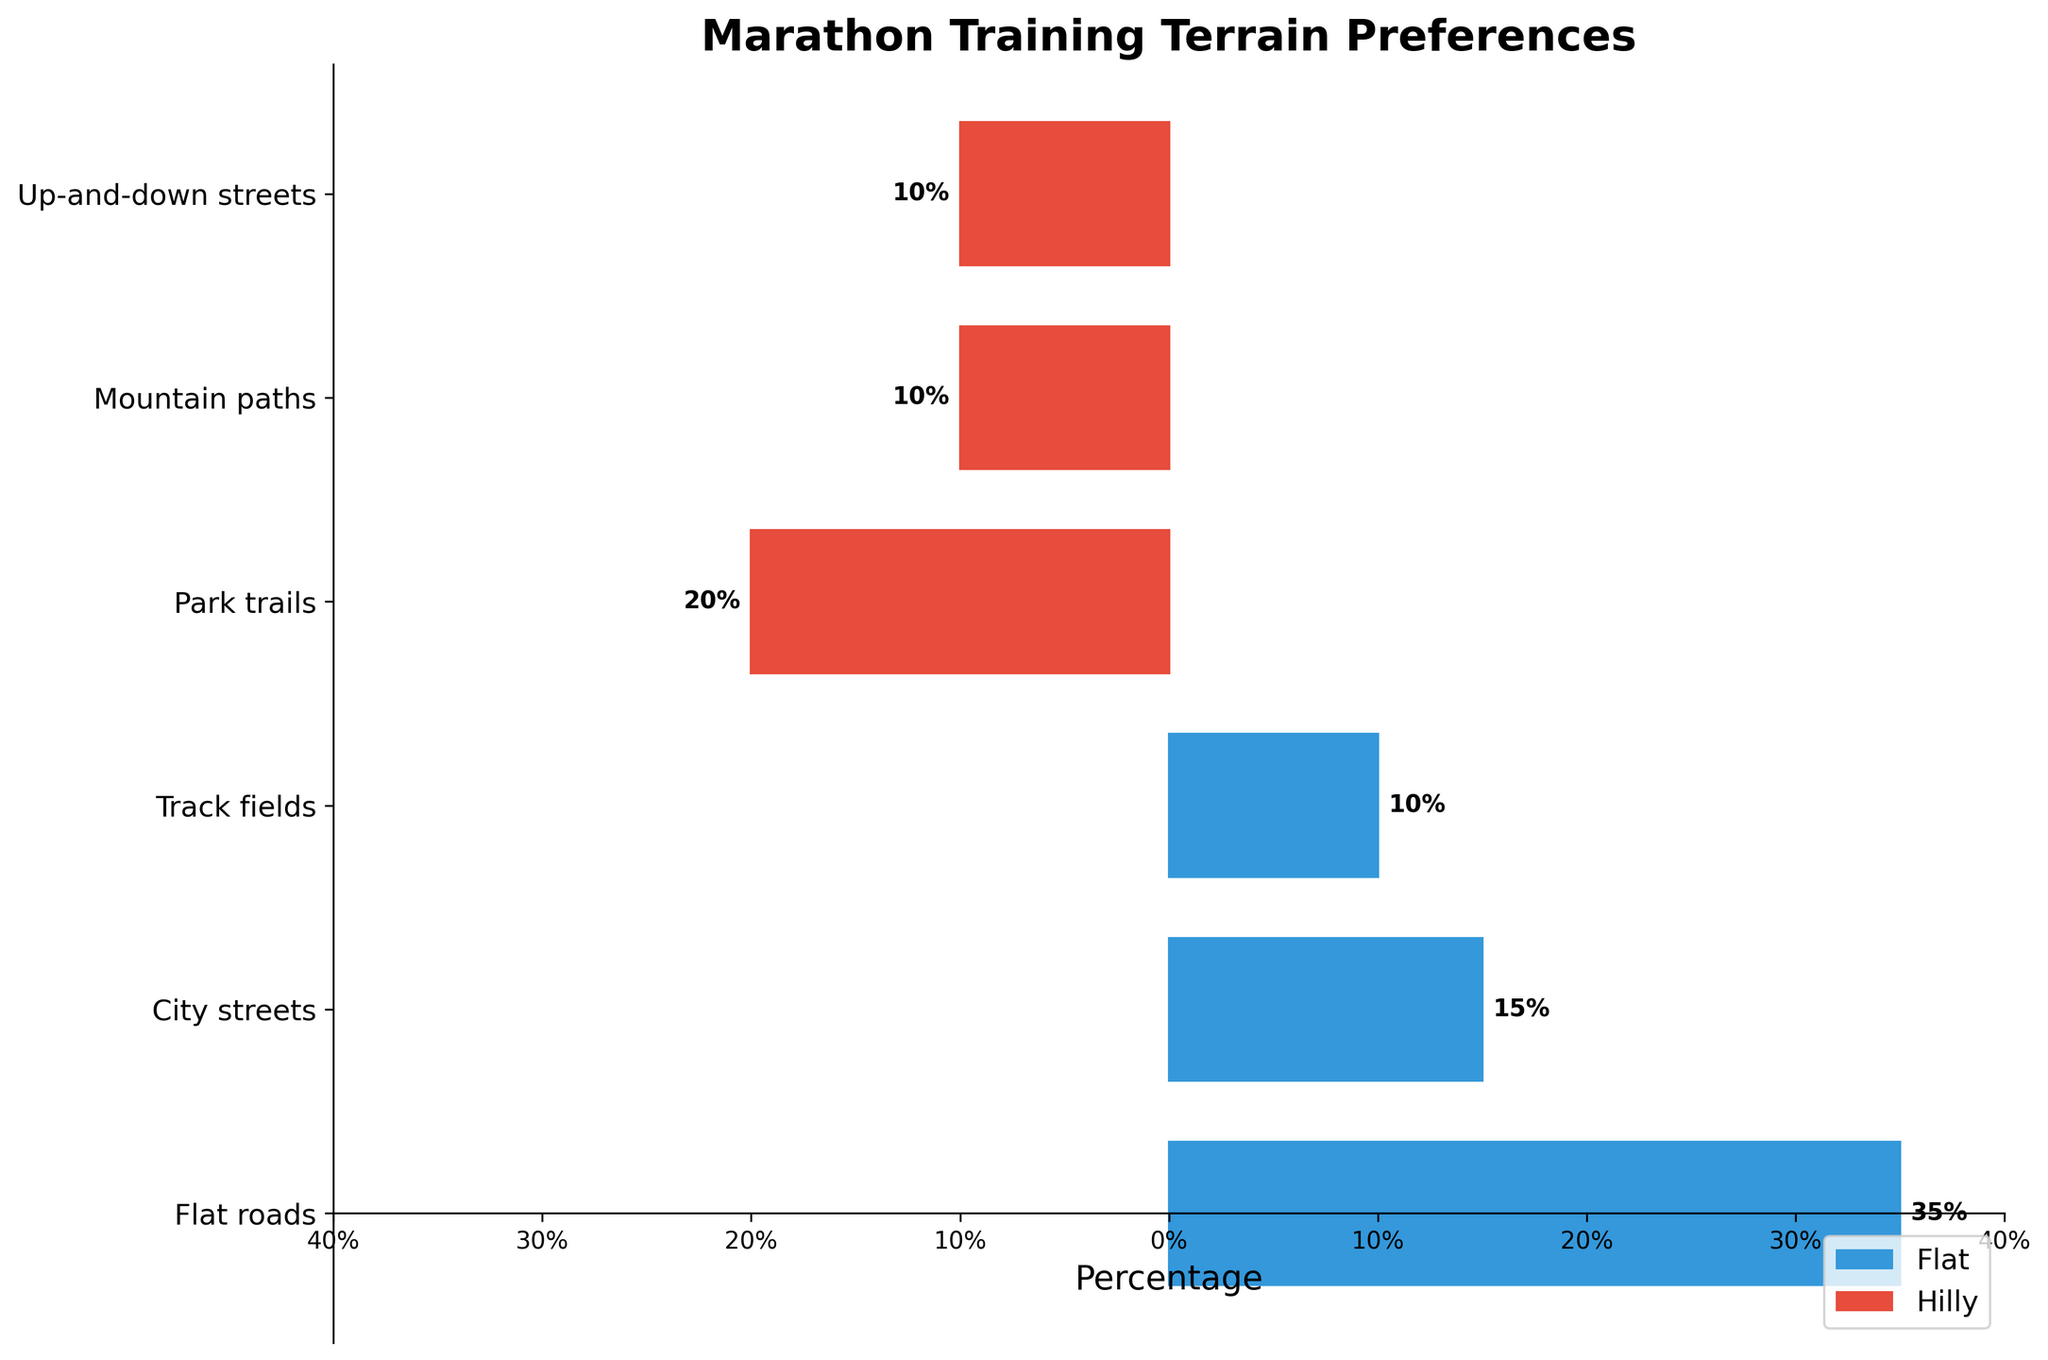What percentage of marathon runners prefer flat roads versus mountain paths? From the figure, the bar for "Flat roads" extends to 35%, while the bar for "Mountain paths" reaches 10%. So, 35% of runners prefer flat roads, in contrast to 10% who prefer mountain paths.
Answer: 35% vs 10% What is the total percentage of runners who prefer hilly terrains? Adding up the percentages for hilly terrains which are "Park trails" (20%), "Mountain paths" (10%), and "Up-and-down streets" (10%), we get 20 + 10 + 10 = 40%.
Answer: 40% Are more runners inclined towards city streets or mountain paths for training? The percentage for "City streets" is 15%, while for "Mountain paths" it's 10%. Since 15% is greater than 10%, more runners prefer city streets to mountain paths.
Answer: City streets Which terrain type has the highest preference among marathon runners? By observing the length of the bars, "Flat roads" has the longest bar at 35%, indicating it's the most preferred terrain.
Answer: Flat roads How does the preference for track fields compare to up-and-down streets? The bars for "Track fields" and "Up-and-down streets" both reach 10%, demonstrating equal preference for these terrains.
Answer: Equal preference Is there a significant difference in preferences between flat terrains and hilly terrains overall? Summing the percentages for flat terrains ("Flat roads" 35%, "City streets" 15%, "Track fields" 10%) gives 35 + 15 + 10 = 60%, while summing the percentages for hilly terrains ("Park trails" 20%, "Mountain paths" 10%, "Up-and-down streets" 10%) gives 40%. The difference is 60% - 40% = 20%.
Answer: 20% difference What is the combined preference percentage for city streets and park trails? Adding the percentages for "City streets" (15%) and "Park trails" (20%), we get 15 + 20 = 35%.
Answer: 35% Which category, flat or hilly, does the terrain type "Up-and-down streets" fall into, and what is its significance in percentage terms? The bar for "Up-and-down streets" is colored the same as other hilly terrains, indicating it's categorized as hilly. Its percentage is 10%, indicating 10% of runners prefer this type of terrain.
Answer: Hilly, 10% What's the average percentage preference for flat terrains? The percentages for flat terrains are "Flat roads" (35%), "City streets" (15%), and "Track fields" (10%). Summing them gives 35 + 15 + 10 = 60%. There are 3 flat terrains, so the average is 60/3 = 20%.
Answer: 20% 